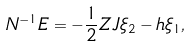Convert formula to latex. <formula><loc_0><loc_0><loc_500><loc_500>N ^ { - 1 } E = - \frac { 1 } { 2 } Z J \xi _ { 2 } - h \xi _ { 1 } ,</formula> 